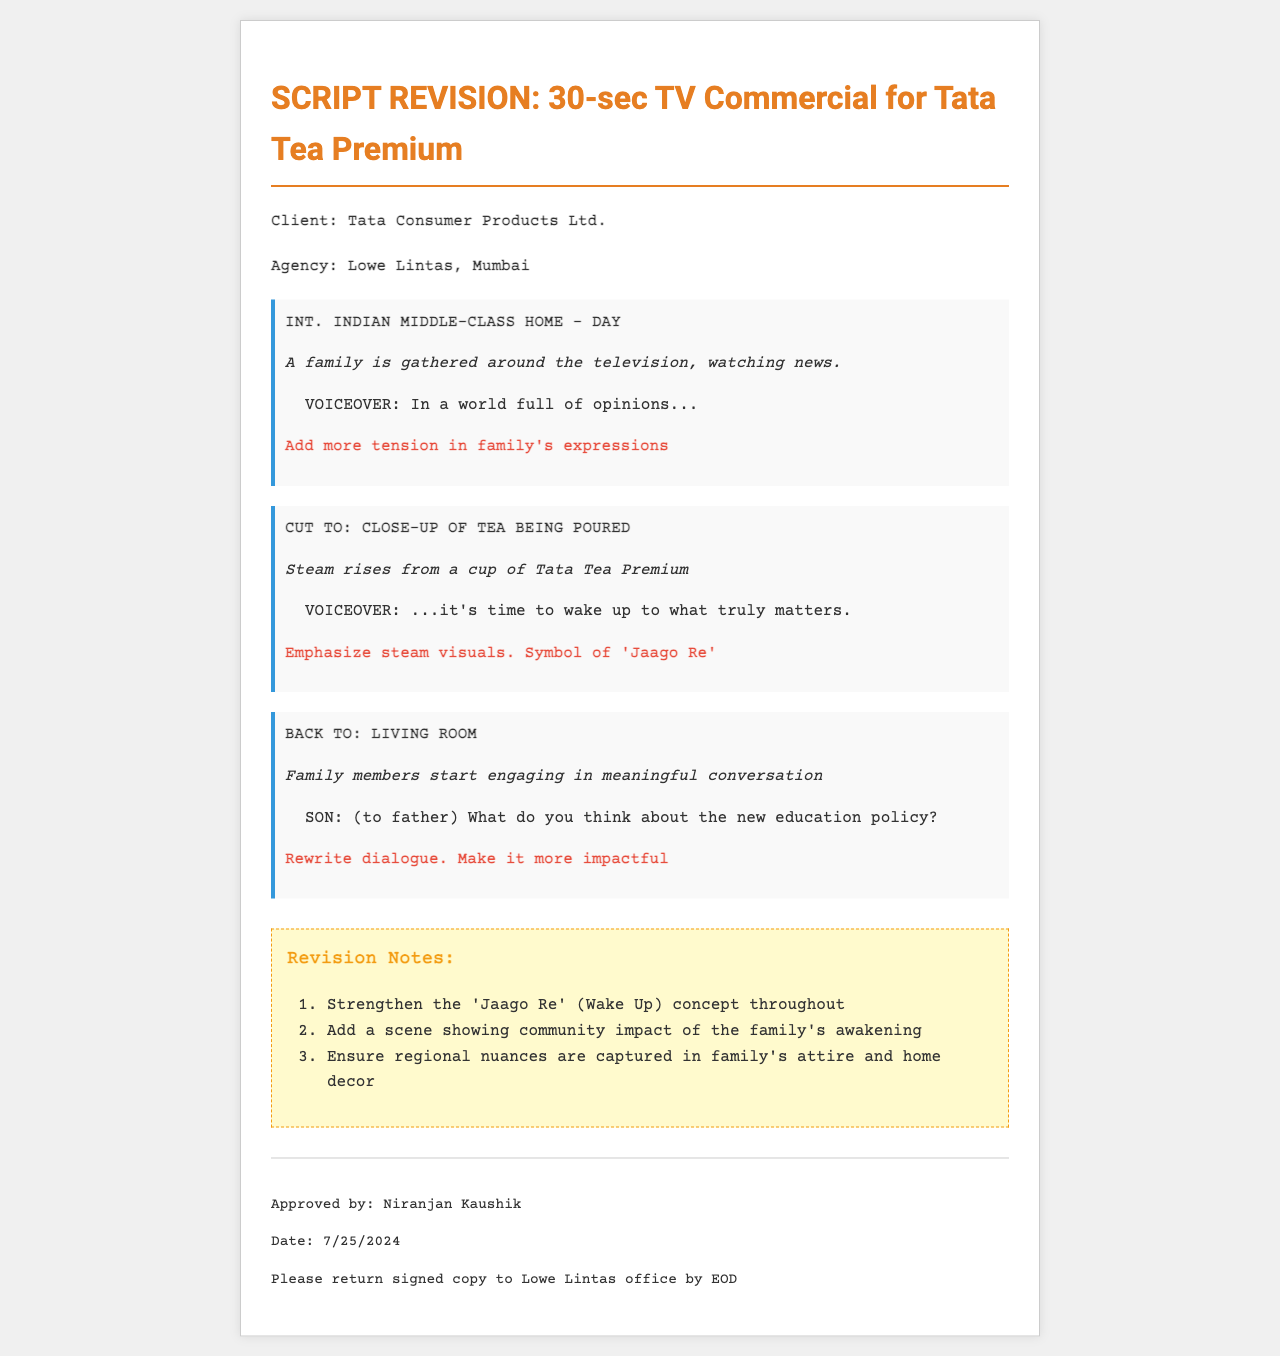What is the client name? The document mentions that the client is Tata Consumer Products Ltd.
Answer: Tata Consumer Products Ltd Who is the agency responsible for the script? The agency referenced in the document is Lowe Lintas, Mumbai.
Answer: Lowe Lintas, Mumbai What is the main concept emphasized in the revision notes? The revision notes indicate that the 'Jaago Re' (Wake Up) concept needs to be strengthened throughout the commercial.
Answer: 'Jaago Re' What type of setting is depicted in the first scene? The first scene takes place in an Indian middle-class home during the day.
Answer: Indian middle-class home How many revision notes are provided in the document? The document lists a total of three revision notes.
Answer: 3 What is requested to be added to the family's expressions in the first scene? The handwritten note suggests to "Add more tension in family's expressions."
Answer: More tension What does the father’s son inquire about in the living room? The son asks the father about the new education policy.
Answer: New education policy What specific visual is suggested to be emphasized when tea is poured? The note requests an emphasis on steam visuals, symbolizing 'Jaago Re.'
Answer: Steam visuals 